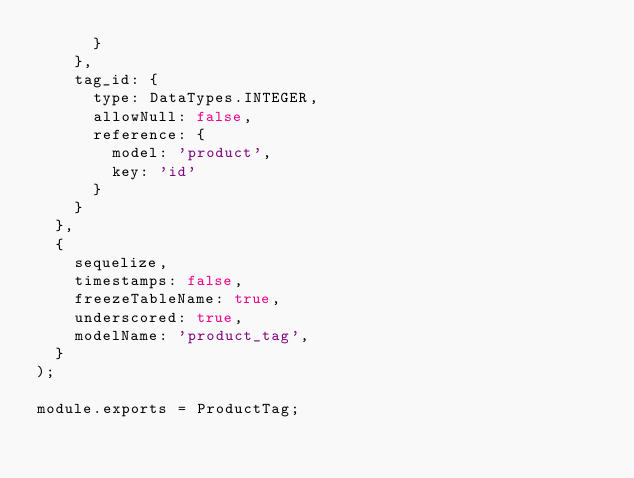Convert code to text. <code><loc_0><loc_0><loc_500><loc_500><_JavaScript_>      }
    },
    tag_id: {
      type: DataTypes.INTEGER,
      allowNull: false,
      reference: {
        model: 'product',
        key: 'id'
      }
    }
  },
  {
    sequelize,
    timestamps: false,
    freezeTableName: true,
    underscored: true,
    modelName: 'product_tag',
  }
);

module.exports = ProductTag;
</code> 